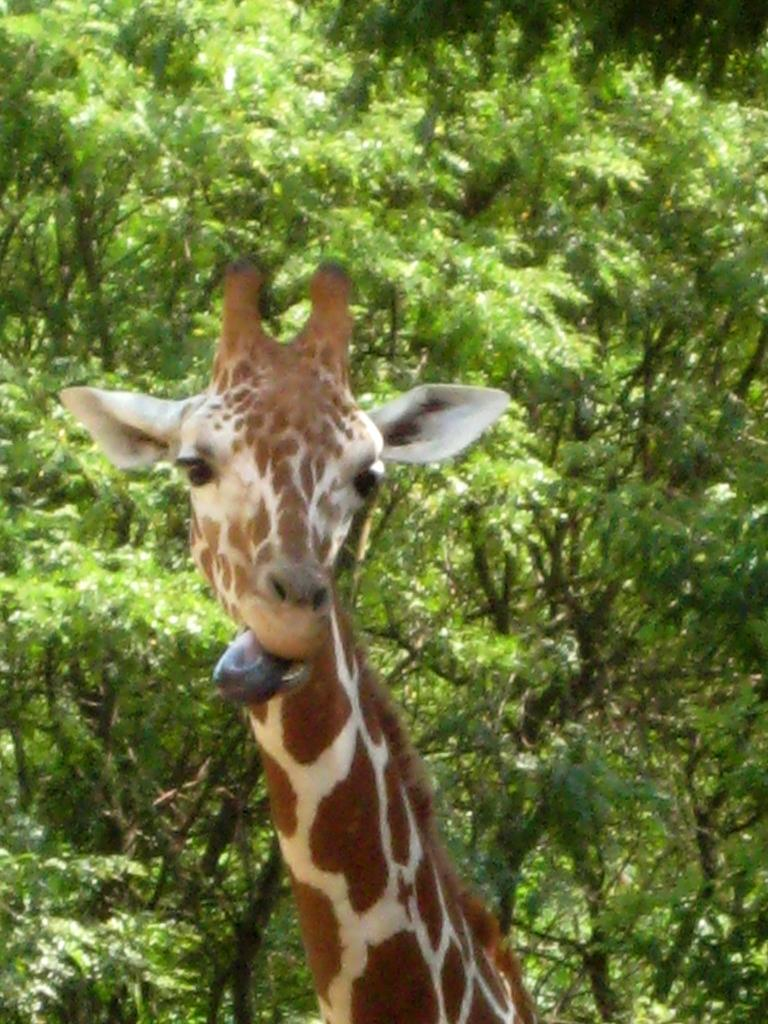What type of animal is in the image? There is a giraffe in the image. What can be seen in the background of the image? There are trees in the background of the image. How does the giraffe cough in the image? Giraffes do not have the ability to cough, as they are animals and do not possess human-like characteristics. 